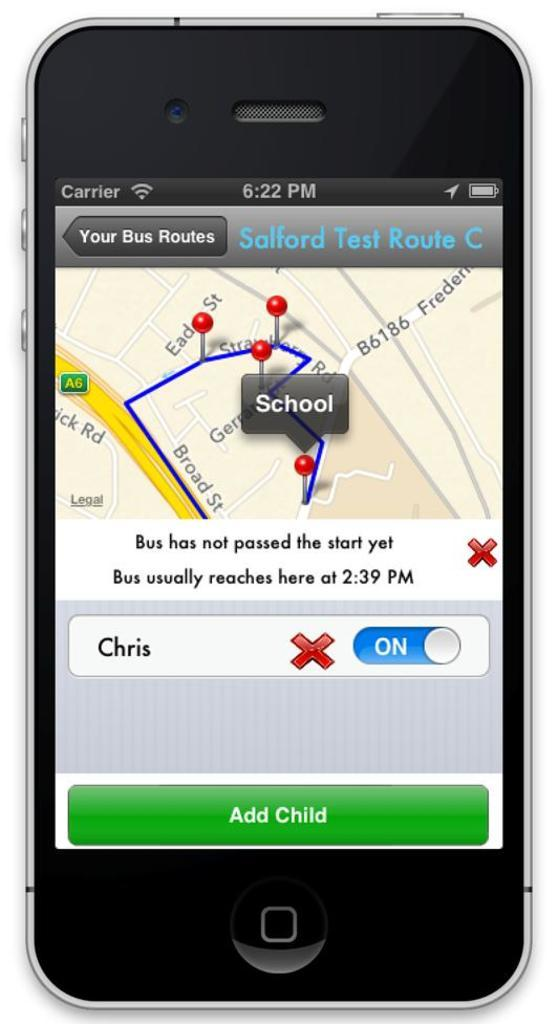<image>
Give a short and clear explanation of the subsequent image. A cell phone display about bus routes shows the location of a school. 